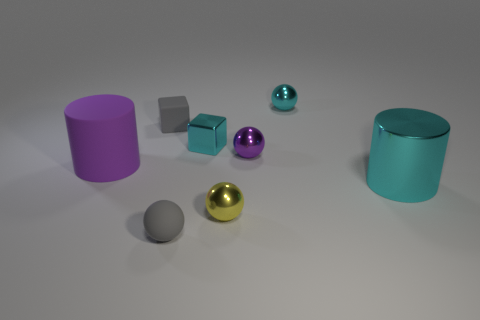Subtract all purple cylinders. How many cylinders are left? 1 Subtract all rubber balls. How many balls are left? 3 Subtract 1 cylinders. How many cylinders are left? 1 Subtract all gray spheres. How many gray cubes are left? 1 Subtract all small gray rubber spheres. Subtract all yellow metal things. How many objects are left? 6 Add 2 small spheres. How many small spheres are left? 6 Add 8 cubes. How many cubes exist? 10 Add 2 cyan metallic things. How many objects exist? 10 Subtract 0 yellow blocks. How many objects are left? 8 Subtract all cylinders. How many objects are left? 6 